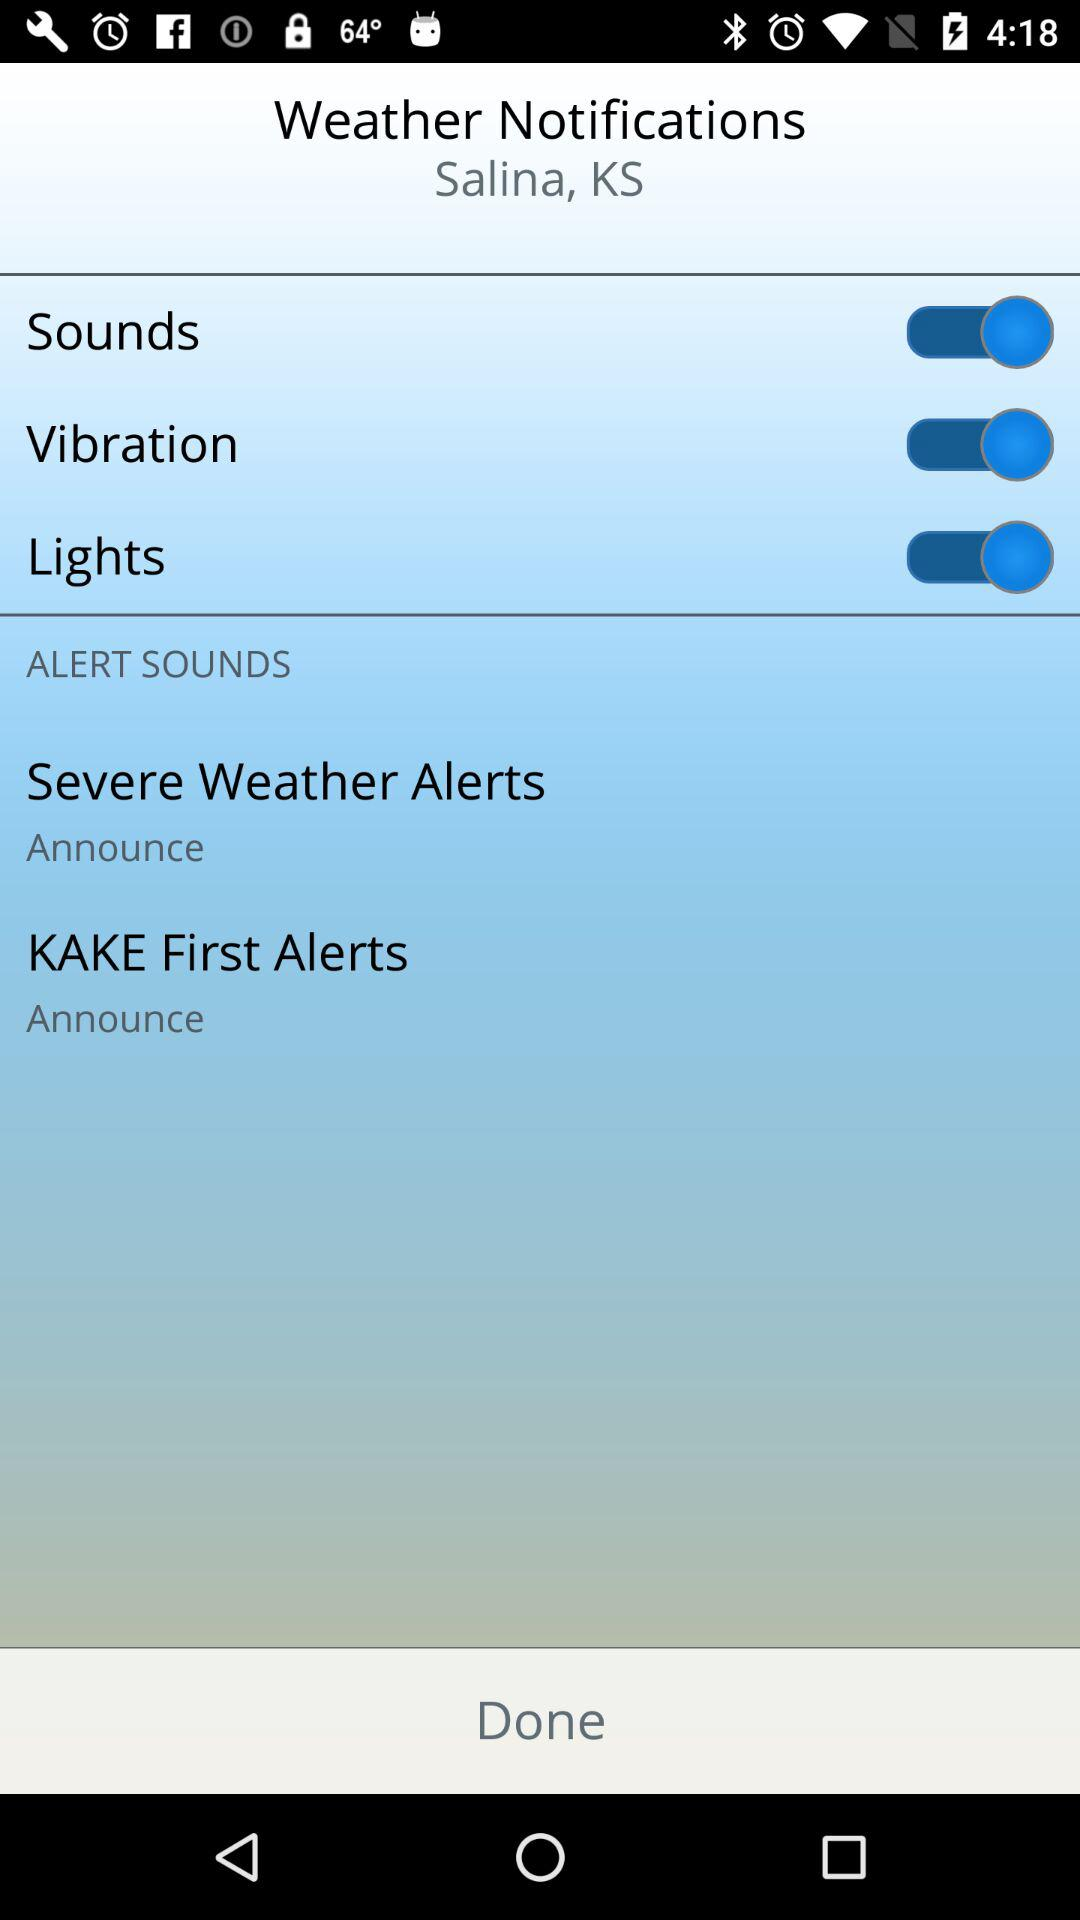How many alert sounds are there?
Answer the question using a single word or phrase. 2 